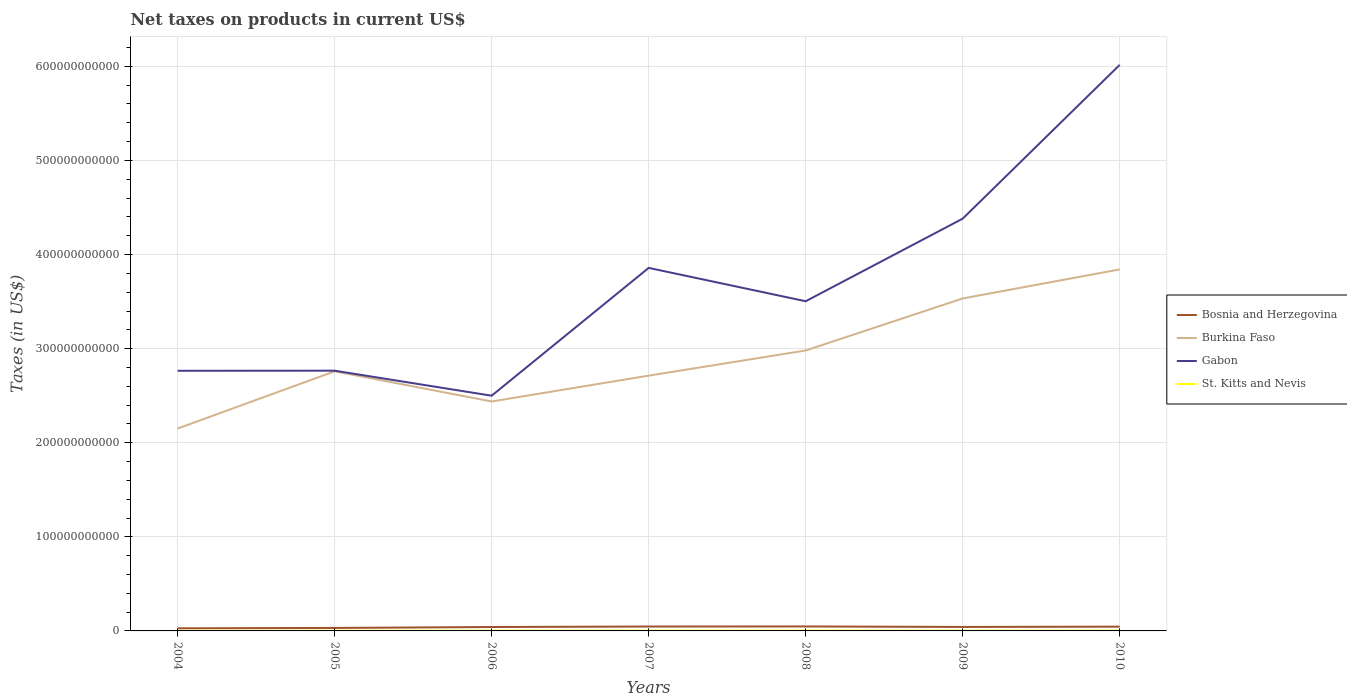Is the number of lines equal to the number of legend labels?
Make the answer very short. Yes. Across all years, what is the maximum net taxes on products in Bosnia and Herzegovina?
Make the answer very short. 2.77e+09. In which year was the net taxes on products in Gabon maximum?
Your answer should be very brief. 2006. What is the total net taxes on products in Gabon in the graph?
Provide a succinct answer. -1.63e+11. What is the difference between the highest and the second highest net taxes on products in Gabon?
Your answer should be compact. 3.52e+11. How many years are there in the graph?
Your answer should be compact. 7. What is the difference between two consecutive major ticks on the Y-axis?
Keep it short and to the point. 1.00e+11. Does the graph contain grids?
Provide a short and direct response. Yes. How are the legend labels stacked?
Your answer should be compact. Vertical. What is the title of the graph?
Give a very brief answer. Net taxes on products in current US$. What is the label or title of the Y-axis?
Offer a terse response. Taxes (in US$). What is the Taxes (in US$) of Bosnia and Herzegovina in 2004?
Your response must be concise. 2.77e+09. What is the Taxes (in US$) in Burkina Faso in 2004?
Give a very brief answer. 2.15e+11. What is the Taxes (in US$) of Gabon in 2004?
Provide a succinct answer. 2.76e+11. What is the Taxes (in US$) in St. Kitts and Nevis in 2004?
Keep it short and to the point. 1.77e+08. What is the Taxes (in US$) in Bosnia and Herzegovina in 2005?
Your answer should be very brief. 3.17e+09. What is the Taxes (in US$) in Burkina Faso in 2005?
Provide a short and direct response. 2.76e+11. What is the Taxes (in US$) in Gabon in 2005?
Ensure brevity in your answer.  2.77e+11. What is the Taxes (in US$) of St. Kitts and Nevis in 2005?
Your answer should be compact. 1.98e+08. What is the Taxes (in US$) in Bosnia and Herzegovina in 2006?
Make the answer very short. 4.14e+09. What is the Taxes (in US$) of Burkina Faso in 2006?
Make the answer very short. 2.44e+11. What is the Taxes (in US$) in Gabon in 2006?
Offer a terse response. 2.50e+11. What is the Taxes (in US$) of St. Kitts and Nevis in 2006?
Give a very brief answer. 2.50e+08. What is the Taxes (in US$) in Bosnia and Herzegovina in 2007?
Offer a very short reply. 4.68e+09. What is the Taxes (in US$) of Burkina Faso in 2007?
Provide a succinct answer. 2.71e+11. What is the Taxes (in US$) of Gabon in 2007?
Your answer should be very brief. 3.86e+11. What is the Taxes (in US$) in St. Kitts and Nevis in 2007?
Provide a succinct answer. 2.38e+08. What is the Taxes (in US$) of Bosnia and Herzegovina in 2008?
Offer a terse response. 4.75e+09. What is the Taxes (in US$) in Burkina Faso in 2008?
Keep it short and to the point. 2.98e+11. What is the Taxes (in US$) of Gabon in 2008?
Give a very brief answer. 3.50e+11. What is the Taxes (in US$) of St. Kitts and Nevis in 2008?
Make the answer very short. 2.68e+08. What is the Taxes (in US$) in Bosnia and Herzegovina in 2009?
Ensure brevity in your answer.  4.24e+09. What is the Taxes (in US$) in Burkina Faso in 2009?
Make the answer very short. 3.53e+11. What is the Taxes (in US$) in Gabon in 2009?
Your answer should be compact. 4.38e+11. What is the Taxes (in US$) of St. Kitts and Nevis in 2009?
Your answer should be very brief. 2.26e+08. What is the Taxes (in US$) in Bosnia and Herzegovina in 2010?
Provide a succinct answer. 4.54e+09. What is the Taxes (in US$) of Burkina Faso in 2010?
Give a very brief answer. 3.84e+11. What is the Taxes (in US$) in Gabon in 2010?
Ensure brevity in your answer.  6.02e+11. What is the Taxes (in US$) of St. Kitts and Nevis in 2010?
Provide a short and direct response. 2.31e+08. Across all years, what is the maximum Taxes (in US$) in Bosnia and Herzegovina?
Ensure brevity in your answer.  4.75e+09. Across all years, what is the maximum Taxes (in US$) of Burkina Faso?
Provide a short and direct response. 3.84e+11. Across all years, what is the maximum Taxes (in US$) in Gabon?
Provide a short and direct response. 6.02e+11. Across all years, what is the maximum Taxes (in US$) in St. Kitts and Nevis?
Your response must be concise. 2.68e+08. Across all years, what is the minimum Taxes (in US$) in Bosnia and Herzegovina?
Ensure brevity in your answer.  2.77e+09. Across all years, what is the minimum Taxes (in US$) of Burkina Faso?
Provide a short and direct response. 2.15e+11. Across all years, what is the minimum Taxes (in US$) in Gabon?
Your answer should be compact. 2.50e+11. Across all years, what is the minimum Taxes (in US$) in St. Kitts and Nevis?
Keep it short and to the point. 1.77e+08. What is the total Taxes (in US$) in Bosnia and Herzegovina in the graph?
Offer a very short reply. 2.83e+1. What is the total Taxes (in US$) in Burkina Faso in the graph?
Your answer should be compact. 2.04e+12. What is the total Taxes (in US$) of Gabon in the graph?
Ensure brevity in your answer.  2.58e+12. What is the total Taxes (in US$) in St. Kitts and Nevis in the graph?
Offer a terse response. 1.59e+09. What is the difference between the Taxes (in US$) of Bosnia and Herzegovina in 2004 and that in 2005?
Make the answer very short. -4.00e+08. What is the difference between the Taxes (in US$) in Burkina Faso in 2004 and that in 2005?
Keep it short and to the point. -6.08e+1. What is the difference between the Taxes (in US$) of Gabon in 2004 and that in 2005?
Your answer should be compact. -9.20e+07. What is the difference between the Taxes (in US$) in St. Kitts and Nevis in 2004 and that in 2005?
Offer a terse response. -2.11e+07. What is the difference between the Taxes (in US$) of Bosnia and Herzegovina in 2004 and that in 2006?
Make the answer very short. -1.38e+09. What is the difference between the Taxes (in US$) of Burkina Faso in 2004 and that in 2006?
Provide a succinct answer. -2.87e+1. What is the difference between the Taxes (in US$) of Gabon in 2004 and that in 2006?
Offer a very short reply. 2.65e+1. What is the difference between the Taxes (in US$) in St. Kitts and Nevis in 2004 and that in 2006?
Give a very brief answer. -7.34e+07. What is the difference between the Taxes (in US$) of Bosnia and Herzegovina in 2004 and that in 2007?
Keep it short and to the point. -1.91e+09. What is the difference between the Taxes (in US$) in Burkina Faso in 2004 and that in 2007?
Give a very brief answer. -5.62e+1. What is the difference between the Taxes (in US$) in Gabon in 2004 and that in 2007?
Your response must be concise. -1.09e+11. What is the difference between the Taxes (in US$) in St. Kitts and Nevis in 2004 and that in 2007?
Ensure brevity in your answer.  -6.18e+07. What is the difference between the Taxes (in US$) in Bosnia and Herzegovina in 2004 and that in 2008?
Ensure brevity in your answer.  -1.98e+09. What is the difference between the Taxes (in US$) in Burkina Faso in 2004 and that in 2008?
Your response must be concise. -8.30e+1. What is the difference between the Taxes (in US$) of Gabon in 2004 and that in 2008?
Ensure brevity in your answer.  -7.39e+1. What is the difference between the Taxes (in US$) of St. Kitts and Nevis in 2004 and that in 2008?
Offer a very short reply. -9.12e+07. What is the difference between the Taxes (in US$) in Bosnia and Herzegovina in 2004 and that in 2009?
Give a very brief answer. -1.47e+09. What is the difference between the Taxes (in US$) of Burkina Faso in 2004 and that in 2009?
Offer a very short reply. -1.38e+11. What is the difference between the Taxes (in US$) in Gabon in 2004 and that in 2009?
Ensure brevity in your answer.  -1.62e+11. What is the difference between the Taxes (in US$) of St. Kitts and Nevis in 2004 and that in 2009?
Ensure brevity in your answer.  -4.98e+07. What is the difference between the Taxes (in US$) of Bosnia and Herzegovina in 2004 and that in 2010?
Ensure brevity in your answer.  -1.77e+09. What is the difference between the Taxes (in US$) in Burkina Faso in 2004 and that in 2010?
Your answer should be very brief. -1.69e+11. What is the difference between the Taxes (in US$) of Gabon in 2004 and that in 2010?
Make the answer very short. -3.25e+11. What is the difference between the Taxes (in US$) of St. Kitts and Nevis in 2004 and that in 2010?
Keep it short and to the point. -5.47e+07. What is the difference between the Taxes (in US$) of Bosnia and Herzegovina in 2005 and that in 2006?
Your response must be concise. -9.76e+08. What is the difference between the Taxes (in US$) of Burkina Faso in 2005 and that in 2006?
Your answer should be compact. 3.21e+1. What is the difference between the Taxes (in US$) of Gabon in 2005 and that in 2006?
Your answer should be compact. 2.66e+1. What is the difference between the Taxes (in US$) in St. Kitts and Nevis in 2005 and that in 2006?
Provide a short and direct response. -5.24e+07. What is the difference between the Taxes (in US$) in Bosnia and Herzegovina in 2005 and that in 2007?
Make the answer very short. -1.51e+09. What is the difference between the Taxes (in US$) of Burkina Faso in 2005 and that in 2007?
Keep it short and to the point. 4.60e+09. What is the difference between the Taxes (in US$) in Gabon in 2005 and that in 2007?
Offer a terse response. -1.09e+11. What is the difference between the Taxes (in US$) in St. Kitts and Nevis in 2005 and that in 2007?
Give a very brief answer. -4.08e+07. What is the difference between the Taxes (in US$) of Bosnia and Herzegovina in 2005 and that in 2008?
Your response must be concise. -1.58e+09. What is the difference between the Taxes (in US$) of Burkina Faso in 2005 and that in 2008?
Offer a terse response. -2.21e+1. What is the difference between the Taxes (in US$) of Gabon in 2005 and that in 2008?
Keep it short and to the point. -7.38e+1. What is the difference between the Taxes (in US$) of St. Kitts and Nevis in 2005 and that in 2008?
Give a very brief answer. -7.01e+07. What is the difference between the Taxes (in US$) in Bosnia and Herzegovina in 2005 and that in 2009?
Your response must be concise. -1.07e+09. What is the difference between the Taxes (in US$) in Burkina Faso in 2005 and that in 2009?
Provide a succinct answer. -7.74e+1. What is the difference between the Taxes (in US$) of Gabon in 2005 and that in 2009?
Provide a succinct answer. -1.62e+11. What is the difference between the Taxes (in US$) of St. Kitts and Nevis in 2005 and that in 2009?
Make the answer very short. -2.87e+07. What is the difference between the Taxes (in US$) in Bosnia and Herzegovina in 2005 and that in 2010?
Offer a very short reply. -1.37e+09. What is the difference between the Taxes (in US$) in Burkina Faso in 2005 and that in 2010?
Give a very brief answer. -1.08e+11. What is the difference between the Taxes (in US$) in Gabon in 2005 and that in 2010?
Offer a terse response. -3.25e+11. What is the difference between the Taxes (in US$) of St. Kitts and Nevis in 2005 and that in 2010?
Give a very brief answer. -3.37e+07. What is the difference between the Taxes (in US$) in Bosnia and Herzegovina in 2006 and that in 2007?
Your answer should be compact. -5.37e+08. What is the difference between the Taxes (in US$) in Burkina Faso in 2006 and that in 2007?
Provide a succinct answer. -2.75e+1. What is the difference between the Taxes (in US$) of Gabon in 2006 and that in 2007?
Offer a very short reply. -1.36e+11. What is the difference between the Taxes (in US$) of St. Kitts and Nevis in 2006 and that in 2007?
Give a very brief answer. 1.16e+07. What is the difference between the Taxes (in US$) of Bosnia and Herzegovina in 2006 and that in 2008?
Your answer should be compact. -6.02e+08. What is the difference between the Taxes (in US$) in Burkina Faso in 2006 and that in 2008?
Offer a very short reply. -5.42e+1. What is the difference between the Taxes (in US$) of Gabon in 2006 and that in 2008?
Your answer should be very brief. -1.00e+11. What is the difference between the Taxes (in US$) of St. Kitts and Nevis in 2006 and that in 2008?
Your response must be concise. -1.77e+07. What is the difference between the Taxes (in US$) of Bosnia and Herzegovina in 2006 and that in 2009?
Your answer should be compact. -9.48e+07. What is the difference between the Taxes (in US$) in Burkina Faso in 2006 and that in 2009?
Your response must be concise. -1.09e+11. What is the difference between the Taxes (in US$) in Gabon in 2006 and that in 2009?
Make the answer very short. -1.88e+11. What is the difference between the Taxes (in US$) in St. Kitts and Nevis in 2006 and that in 2009?
Keep it short and to the point. 2.37e+07. What is the difference between the Taxes (in US$) in Bosnia and Herzegovina in 2006 and that in 2010?
Make the answer very short. -3.94e+08. What is the difference between the Taxes (in US$) in Burkina Faso in 2006 and that in 2010?
Offer a very short reply. -1.40e+11. What is the difference between the Taxes (in US$) of Gabon in 2006 and that in 2010?
Make the answer very short. -3.52e+11. What is the difference between the Taxes (in US$) in St. Kitts and Nevis in 2006 and that in 2010?
Your response must be concise. 1.87e+07. What is the difference between the Taxes (in US$) of Bosnia and Herzegovina in 2007 and that in 2008?
Give a very brief answer. -6.51e+07. What is the difference between the Taxes (in US$) of Burkina Faso in 2007 and that in 2008?
Provide a succinct answer. -2.67e+1. What is the difference between the Taxes (in US$) of Gabon in 2007 and that in 2008?
Your answer should be very brief. 3.54e+1. What is the difference between the Taxes (in US$) in St. Kitts and Nevis in 2007 and that in 2008?
Make the answer very short. -2.94e+07. What is the difference between the Taxes (in US$) of Bosnia and Herzegovina in 2007 and that in 2009?
Ensure brevity in your answer.  4.42e+08. What is the difference between the Taxes (in US$) in Burkina Faso in 2007 and that in 2009?
Make the answer very short. -8.20e+1. What is the difference between the Taxes (in US$) of Gabon in 2007 and that in 2009?
Keep it short and to the point. -5.23e+1. What is the difference between the Taxes (in US$) in St. Kitts and Nevis in 2007 and that in 2009?
Ensure brevity in your answer.  1.21e+07. What is the difference between the Taxes (in US$) of Bosnia and Herzegovina in 2007 and that in 2010?
Offer a terse response. 1.43e+08. What is the difference between the Taxes (in US$) of Burkina Faso in 2007 and that in 2010?
Keep it short and to the point. -1.13e+11. What is the difference between the Taxes (in US$) of Gabon in 2007 and that in 2010?
Your response must be concise. -2.16e+11. What is the difference between the Taxes (in US$) in St. Kitts and Nevis in 2007 and that in 2010?
Offer a very short reply. 7.09e+06. What is the difference between the Taxes (in US$) of Bosnia and Herzegovina in 2008 and that in 2009?
Offer a very short reply. 5.07e+08. What is the difference between the Taxes (in US$) in Burkina Faso in 2008 and that in 2009?
Your answer should be very brief. -5.53e+1. What is the difference between the Taxes (in US$) in Gabon in 2008 and that in 2009?
Keep it short and to the point. -8.78e+1. What is the difference between the Taxes (in US$) of St. Kitts and Nevis in 2008 and that in 2009?
Your answer should be compact. 4.14e+07. What is the difference between the Taxes (in US$) in Bosnia and Herzegovina in 2008 and that in 2010?
Your response must be concise. 2.08e+08. What is the difference between the Taxes (in US$) of Burkina Faso in 2008 and that in 2010?
Offer a very short reply. -8.61e+1. What is the difference between the Taxes (in US$) of Gabon in 2008 and that in 2010?
Your answer should be very brief. -2.51e+11. What is the difference between the Taxes (in US$) of St. Kitts and Nevis in 2008 and that in 2010?
Make the answer very short. 3.64e+07. What is the difference between the Taxes (in US$) in Bosnia and Herzegovina in 2009 and that in 2010?
Make the answer very short. -2.99e+08. What is the difference between the Taxes (in US$) of Burkina Faso in 2009 and that in 2010?
Provide a succinct answer. -3.09e+1. What is the difference between the Taxes (in US$) of Gabon in 2009 and that in 2010?
Keep it short and to the point. -1.63e+11. What is the difference between the Taxes (in US$) of St. Kitts and Nevis in 2009 and that in 2010?
Your answer should be compact. -4.97e+06. What is the difference between the Taxes (in US$) of Bosnia and Herzegovina in 2004 and the Taxes (in US$) of Burkina Faso in 2005?
Your answer should be compact. -2.73e+11. What is the difference between the Taxes (in US$) of Bosnia and Herzegovina in 2004 and the Taxes (in US$) of Gabon in 2005?
Offer a very short reply. -2.74e+11. What is the difference between the Taxes (in US$) in Bosnia and Herzegovina in 2004 and the Taxes (in US$) in St. Kitts and Nevis in 2005?
Keep it short and to the point. 2.57e+09. What is the difference between the Taxes (in US$) of Burkina Faso in 2004 and the Taxes (in US$) of Gabon in 2005?
Your answer should be very brief. -6.15e+1. What is the difference between the Taxes (in US$) in Burkina Faso in 2004 and the Taxes (in US$) in St. Kitts and Nevis in 2005?
Your answer should be compact. 2.15e+11. What is the difference between the Taxes (in US$) in Gabon in 2004 and the Taxes (in US$) in St. Kitts and Nevis in 2005?
Your answer should be very brief. 2.76e+11. What is the difference between the Taxes (in US$) in Bosnia and Herzegovina in 2004 and the Taxes (in US$) in Burkina Faso in 2006?
Give a very brief answer. -2.41e+11. What is the difference between the Taxes (in US$) of Bosnia and Herzegovina in 2004 and the Taxes (in US$) of Gabon in 2006?
Make the answer very short. -2.47e+11. What is the difference between the Taxes (in US$) of Bosnia and Herzegovina in 2004 and the Taxes (in US$) of St. Kitts and Nevis in 2006?
Offer a terse response. 2.52e+09. What is the difference between the Taxes (in US$) of Burkina Faso in 2004 and the Taxes (in US$) of Gabon in 2006?
Ensure brevity in your answer.  -3.49e+1. What is the difference between the Taxes (in US$) in Burkina Faso in 2004 and the Taxes (in US$) in St. Kitts and Nevis in 2006?
Provide a short and direct response. 2.15e+11. What is the difference between the Taxes (in US$) of Gabon in 2004 and the Taxes (in US$) of St. Kitts and Nevis in 2006?
Ensure brevity in your answer.  2.76e+11. What is the difference between the Taxes (in US$) of Bosnia and Herzegovina in 2004 and the Taxes (in US$) of Burkina Faso in 2007?
Your response must be concise. -2.69e+11. What is the difference between the Taxes (in US$) in Bosnia and Herzegovina in 2004 and the Taxes (in US$) in Gabon in 2007?
Offer a terse response. -3.83e+11. What is the difference between the Taxes (in US$) in Bosnia and Herzegovina in 2004 and the Taxes (in US$) in St. Kitts and Nevis in 2007?
Your answer should be very brief. 2.53e+09. What is the difference between the Taxes (in US$) of Burkina Faso in 2004 and the Taxes (in US$) of Gabon in 2007?
Ensure brevity in your answer.  -1.71e+11. What is the difference between the Taxes (in US$) in Burkina Faso in 2004 and the Taxes (in US$) in St. Kitts and Nevis in 2007?
Your answer should be compact. 2.15e+11. What is the difference between the Taxes (in US$) in Gabon in 2004 and the Taxes (in US$) in St. Kitts and Nevis in 2007?
Provide a succinct answer. 2.76e+11. What is the difference between the Taxes (in US$) of Bosnia and Herzegovina in 2004 and the Taxes (in US$) of Burkina Faso in 2008?
Your response must be concise. -2.95e+11. What is the difference between the Taxes (in US$) of Bosnia and Herzegovina in 2004 and the Taxes (in US$) of Gabon in 2008?
Ensure brevity in your answer.  -3.48e+11. What is the difference between the Taxes (in US$) of Bosnia and Herzegovina in 2004 and the Taxes (in US$) of St. Kitts and Nevis in 2008?
Provide a short and direct response. 2.50e+09. What is the difference between the Taxes (in US$) of Burkina Faso in 2004 and the Taxes (in US$) of Gabon in 2008?
Ensure brevity in your answer.  -1.35e+11. What is the difference between the Taxes (in US$) of Burkina Faso in 2004 and the Taxes (in US$) of St. Kitts and Nevis in 2008?
Offer a very short reply. 2.15e+11. What is the difference between the Taxes (in US$) in Gabon in 2004 and the Taxes (in US$) in St. Kitts and Nevis in 2008?
Provide a short and direct response. 2.76e+11. What is the difference between the Taxes (in US$) in Bosnia and Herzegovina in 2004 and the Taxes (in US$) in Burkina Faso in 2009?
Give a very brief answer. -3.51e+11. What is the difference between the Taxes (in US$) in Bosnia and Herzegovina in 2004 and the Taxes (in US$) in Gabon in 2009?
Your answer should be very brief. -4.35e+11. What is the difference between the Taxes (in US$) in Bosnia and Herzegovina in 2004 and the Taxes (in US$) in St. Kitts and Nevis in 2009?
Keep it short and to the point. 2.54e+09. What is the difference between the Taxes (in US$) in Burkina Faso in 2004 and the Taxes (in US$) in Gabon in 2009?
Give a very brief answer. -2.23e+11. What is the difference between the Taxes (in US$) in Burkina Faso in 2004 and the Taxes (in US$) in St. Kitts and Nevis in 2009?
Provide a short and direct response. 2.15e+11. What is the difference between the Taxes (in US$) of Gabon in 2004 and the Taxes (in US$) of St. Kitts and Nevis in 2009?
Your answer should be very brief. 2.76e+11. What is the difference between the Taxes (in US$) of Bosnia and Herzegovina in 2004 and the Taxes (in US$) of Burkina Faso in 2010?
Make the answer very short. -3.81e+11. What is the difference between the Taxes (in US$) in Bosnia and Herzegovina in 2004 and the Taxes (in US$) in Gabon in 2010?
Offer a very short reply. -5.99e+11. What is the difference between the Taxes (in US$) in Bosnia and Herzegovina in 2004 and the Taxes (in US$) in St. Kitts and Nevis in 2010?
Your response must be concise. 2.54e+09. What is the difference between the Taxes (in US$) in Burkina Faso in 2004 and the Taxes (in US$) in Gabon in 2010?
Keep it short and to the point. -3.86e+11. What is the difference between the Taxes (in US$) in Burkina Faso in 2004 and the Taxes (in US$) in St. Kitts and Nevis in 2010?
Your answer should be compact. 2.15e+11. What is the difference between the Taxes (in US$) in Gabon in 2004 and the Taxes (in US$) in St. Kitts and Nevis in 2010?
Provide a succinct answer. 2.76e+11. What is the difference between the Taxes (in US$) in Bosnia and Herzegovina in 2005 and the Taxes (in US$) in Burkina Faso in 2006?
Ensure brevity in your answer.  -2.41e+11. What is the difference between the Taxes (in US$) in Bosnia and Herzegovina in 2005 and the Taxes (in US$) in Gabon in 2006?
Ensure brevity in your answer.  -2.47e+11. What is the difference between the Taxes (in US$) of Bosnia and Herzegovina in 2005 and the Taxes (in US$) of St. Kitts and Nevis in 2006?
Ensure brevity in your answer.  2.92e+09. What is the difference between the Taxes (in US$) in Burkina Faso in 2005 and the Taxes (in US$) in Gabon in 2006?
Ensure brevity in your answer.  2.59e+1. What is the difference between the Taxes (in US$) of Burkina Faso in 2005 and the Taxes (in US$) of St. Kitts and Nevis in 2006?
Your answer should be compact. 2.76e+11. What is the difference between the Taxes (in US$) of Gabon in 2005 and the Taxes (in US$) of St. Kitts and Nevis in 2006?
Provide a short and direct response. 2.76e+11. What is the difference between the Taxes (in US$) of Bosnia and Herzegovina in 2005 and the Taxes (in US$) of Burkina Faso in 2007?
Offer a terse response. -2.68e+11. What is the difference between the Taxes (in US$) in Bosnia and Herzegovina in 2005 and the Taxes (in US$) in Gabon in 2007?
Offer a very short reply. -3.83e+11. What is the difference between the Taxes (in US$) of Bosnia and Herzegovina in 2005 and the Taxes (in US$) of St. Kitts and Nevis in 2007?
Your answer should be very brief. 2.93e+09. What is the difference between the Taxes (in US$) of Burkina Faso in 2005 and the Taxes (in US$) of Gabon in 2007?
Provide a short and direct response. -1.10e+11. What is the difference between the Taxes (in US$) in Burkina Faso in 2005 and the Taxes (in US$) in St. Kitts and Nevis in 2007?
Provide a short and direct response. 2.76e+11. What is the difference between the Taxes (in US$) in Gabon in 2005 and the Taxes (in US$) in St. Kitts and Nevis in 2007?
Your answer should be very brief. 2.76e+11. What is the difference between the Taxes (in US$) in Bosnia and Herzegovina in 2005 and the Taxes (in US$) in Burkina Faso in 2008?
Your response must be concise. -2.95e+11. What is the difference between the Taxes (in US$) of Bosnia and Herzegovina in 2005 and the Taxes (in US$) of Gabon in 2008?
Your answer should be very brief. -3.47e+11. What is the difference between the Taxes (in US$) of Bosnia and Herzegovina in 2005 and the Taxes (in US$) of St. Kitts and Nevis in 2008?
Give a very brief answer. 2.90e+09. What is the difference between the Taxes (in US$) of Burkina Faso in 2005 and the Taxes (in US$) of Gabon in 2008?
Your answer should be compact. -7.45e+1. What is the difference between the Taxes (in US$) of Burkina Faso in 2005 and the Taxes (in US$) of St. Kitts and Nevis in 2008?
Offer a very short reply. 2.76e+11. What is the difference between the Taxes (in US$) of Gabon in 2005 and the Taxes (in US$) of St. Kitts and Nevis in 2008?
Ensure brevity in your answer.  2.76e+11. What is the difference between the Taxes (in US$) of Bosnia and Herzegovina in 2005 and the Taxes (in US$) of Burkina Faso in 2009?
Provide a short and direct response. -3.50e+11. What is the difference between the Taxes (in US$) of Bosnia and Herzegovina in 2005 and the Taxes (in US$) of Gabon in 2009?
Offer a very short reply. -4.35e+11. What is the difference between the Taxes (in US$) in Bosnia and Herzegovina in 2005 and the Taxes (in US$) in St. Kitts and Nevis in 2009?
Give a very brief answer. 2.94e+09. What is the difference between the Taxes (in US$) of Burkina Faso in 2005 and the Taxes (in US$) of Gabon in 2009?
Your answer should be compact. -1.62e+11. What is the difference between the Taxes (in US$) of Burkina Faso in 2005 and the Taxes (in US$) of St. Kitts and Nevis in 2009?
Your response must be concise. 2.76e+11. What is the difference between the Taxes (in US$) in Gabon in 2005 and the Taxes (in US$) in St. Kitts and Nevis in 2009?
Your response must be concise. 2.76e+11. What is the difference between the Taxes (in US$) of Bosnia and Herzegovina in 2005 and the Taxes (in US$) of Burkina Faso in 2010?
Provide a succinct answer. -3.81e+11. What is the difference between the Taxes (in US$) in Bosnia and Herzegovina in 2005 and the Taxes (in US$) in Gabon in 2010?
Keep it short and to the point. -5.98e+11. What is the difference between the Taxes (in US$) in Bosnia and Herzegovina in 2005 and the Taxes (in US$) in St. Kitts and Nevis in 2010?
Your answer should be very brief. 2.94e+09. What is the difference between the Taxes (in US$) of Burkina Faso in 2005 and the Taxes (in US$) of Gabon in 2010?
Your response must be concise. -3.26e+11. What is the difference between the Taxes (in US$) in Burkina Faso in 2005 and the Taxes (in US$) in St. Kitts and Nevis in 2010?
Offer a very short reply. 2.76e+11. What is the difference between the Taxes (in US$) of Gabon in 2005 and the Taxes (in US$) of St. Kitts and Nevis in 2010?
Make the answer very short. 2.76e+11. What is the difference between the Taxes (in US$) in Bosnia and Herzegovina in 2006 and the Taxes (in US$) in Burkina Faso in 2007?
Your answer should be compact. -2.67e+11. What is the difference between the Taxes (in US$) of Bosnia and Herzegovina in 2006 and the Taxes (in US$) of Gabon in 2007?
Give a very brief answer. -3.82e+11. What is the difference between the Taxes (in US$) in Bosnia and Herzegovina in 2006 and the Taxes (in US$) in St. Kitts and Nevis in 2007?
Make the answer very short. 3.90e+09. What is the difference between the Taxes (in US$) in Burkina Faso in 2006 and the Taxes (in US$) in Gabon in 2007?
Offer a terse response. -1.42e+11. What is the difference between the Taxes (in US$) in Burkina Faso in 2006 and the Taxes (in US$) in St. Kitts and Nevis in 2007?
Offer a very short reply. 2.44e+11. What is the difference between the Taxes (in US$) in Gabon in 2006 and the Taxes (in US$) in St. Kitts and Nevis in 2007?
Provide a short and direct response. 2.50e+11. What is the difference between the Taxes (in US$) in Bosnia and Herzegovina in 2006 and the Taxes (in US$) in Burkina Faso in 2008?
Keep it short and to the point. -2.94e+11. What is the difference between the Taxes (in US$) of Bosnia and Herzegovina in 2006 and the Taxes (in US$) of Gabon in 2008?
Make the answer very short. -3.46e+11. What is the difference between the Taxes (in US$) in Bosnia and Herzegovina in 2006 and the Taxes (in US$) in St. Kitts and Nevis in 2008?
Keep it short and to the point. 3.88e+09. What is the difference between the Taxes (in US$) of Burkina Faso in 2006 and the Taxes (in US$) of Gabon in 2008?
Offer a terse response. -1.07e+11. What is the difference between the Taxes (in US$) in Burkina Faso in 2006 and the Taxes (in US$) in St. Kitts and Nevis in 2008?
Your answer should be compact. 2.44e+11. What is the difference between the Taxes (in US$) in Gabon in 2006 and the Taxes (in US$) in St. Kitts and Nevis in 2008?
Give a very brief answer. 2.50e+11. What is the difference between the Taxes (in US$) in Bosnia and Herzegovina in 2006 and the Taxes (in US$) in Burkina Faso in 2009?
Your answer should be very brief. -3.49e+11. What is the difference between the Taxes (in US$) of Bosnia and Herzegovina in 2006 and the Taxes (in US$) of Gabon in 2009?
Your answer should be very brief. -4.34e+11. What is the difference between the Taxes (in US$) in Bosnia and Herzegovina in 2006 and the Taxes (in US$) in St. Kitts and Nevis in 2009?
Keep it short and to the point. 3.92e+09. What is the difference between the Taxes (in US$) in Burkina Faso in 2006 and the Taxes (in US$) in Gabon in 2009?
Make the answer very short. -1.94e+11. What is the difference between the Taxes (in US$) in Burkina Faso in 2006 and the Taxes (in US$) in St. Kitts and Nevis in 2009?
Your answer should be compact. 2.44e+11. What is the difference between the Taxes (in US$) in Gabon in 2006 and the Taxes (in US$) in St. Kitts and Nevis in 2009?
Ensure brevity in your answer.  2.50e+11. What is the difference between the Taxes (in US$) in Bosnia and Herzegovina in 2006 and the Taxes (in US$) in Burkina Faso in 2010?
Keep it short and to the point. -3.80e+11. What is the difference between the Taxes (in US$) of Bosnia and Herzegovina in 2006 and the Taxes (in US$) of Gabon in 2010?
Your response must be concise. -5.97e+11. What is the difference between the Taxes (in US$) in Bosnia and Herzegovina in 2006 and the Taxes (in US$) in St. Kitts and Nevis in 2010?
Your answer should be very brief. 3.91e+09. What is the difference between the Taxes (in US$) of Burkina Faso in 2006 and the Taxes (in US$) of Gabon in 2010?
Ensure brevity in your answer.  -3.58e+11. What is the difference between the Taxes (in US$) in Burkina Faso in 2006 and the Taxes (in US$) in St. Kitts and Nevis in 2010?
Your answer should be compact. 2.44e+11. What is the difference between the Taxes (in US$) of Gabon in 2006 and the Taxes (in US$) of St. Kitts and Nevis in 2010?
Offer a very short reply. 2.50e+11. What is the difference between the Taxes (in US$) of Bosnia and Herzegovina in 2007 and the Taxes (in US$) of Burkina Faso in 2008?
Your answer should be very brief. -2.93e+11. What is the difference between the Taxes (in US$) in Bosnia and Herzegovina in 2007 and the Taxes (in US$) in Gabon in 2008?
Offer a terse response. -3.46e+11. What is the difference between the Taxes (in US$) in Bosnia and Herzegovina in 2007 and the Taxes (in US$) in St. Kitts and Nevis in 2008?
Your answer should be very brief. 4.41e+09. What is the difference between the Taxes (in US$) of Burkina Faso in 2007 and the Taxes (in US$) of Gabon in 2008?
Provide a short and direct response. -7.91e+1. What is the difference between the Taxes (in US$) in Burkina Faso in 2007 and the Taxes (in US$) in St. Kitts and Nevis in 2008?
Provide a succinct answer. 2.71e+11. What is the difference between the Taxes (in US$) of Gabon in 2007 and the Taxes (in US$) of St. Kitts and Nevis in 2008?
Offer a very short reply. 3.86e+11. What is the difference between the Taxes (in US$) of Bosnia and Herzegovina in 2007 and the Taxes (in US$) of Burkina Faso in 2009?
Offer a terse response. -3.49e+11. What is the difference between the Taxes (in US$) in Bosnia and Herzegovina in 2007 and the Taxes (in US$) in Gabon in 2009?
Provide a short and direct response. -4.33e+11. What is the difference between the Taxes (in US$) of Bosnia and Herzegovina in 2007 and the Taxes (in US$) of St. Kitts and Nevis in 2009?
Provide a short and direct response. 4.45e+09. What is the difference between the Taxes (in US$) in Burkina Faso in 2007 and the Taxes (in US$) in Gabon in 2009?
Your answer should be very brief. -1.67e+11. What is the difference between the Taxes (in US$) in Burkina Faso in 2007 and the Taxes (in US$) in St. Kitts and Nevis in 2009?
Keep it short and to the point. 2.71e+11. What is the difference between the Taxes (in US$) in Gabon in 2007 and the Taxes (in US$) in St. Kitts and Nevis in 2009?
Offer a terse response. 3.86e+11. What is the difference between the Taxes (in US$) in Bosnia and Herzegovina in 2007 and the Taxes (in US$) in Burkina Faso in 2010?
Offer a terse response. -3.80e+11. What is the difference between the Taxes (in US$) of Bosnia and Herzegovina in 2007 and the Taxes (in US$) of Gabon in 2010?
Your answer should be compact. -5.97e+11. What is the difference between the Taxes (in US$) in Bosnia and Herzegovina in 2007 and the Taxes (in US$) in St. Kitts and Nevis in 2010?
Keep it short and to the point. 4.45e+09. What is the difference between the Taxes (in US$) of Burkina Faso in 2007 and the Taxes (in US$) of Gabon in 2010?
Offer a very short reply. -3.30e+11. What is the difference between the Taxes (in US$) in Burkina Faso in 2007 and the Taxes (in US$) in St. Kitts and Nevis in 2010?
Your response must be concise. 2.71e+11. What is the difference between the Taxes (in US$) in Gabon in 2007 and the Taxes (in US$) in St. Kitts and Nevis in 2010?
Provide a short and direct response. 3.86e+11. What is the difference between the Taxes (in US$) in Bosnia and Herzegovina in 2008 and the Taxes (in US$) in Burkina Faso in 2009?
Give a very brief answer. -3.49e+11. What is the difference between the Taxes (in US$) of Bosnia and Herzegovina in 2008 and the Taxes (in US$) of Gabon in 2009?
Your answer should be compact. -4.33e+11. What is the difference between the Taxes (in US$) of Bosnia and Herzegovina in 2008 and the Taxes (in US$) of St. Kitts and Nevis in 2009?
Provide a short and direct response. 4.52e+09. What is the difference between the Taxes (in US$) in Burkina Faso in 2008 and the Taxes (in US$) in Gabon in 2009?
Ensure brevity in your answer.  -1.40e+11. What is the difference between the Taxes (in US$) in Burkina Faso in 2008 and the Taxes (in US$) in St. Kitts and Nevis in 2009?
Make the answer very short. 2.98e+11. What is the difference between the Taxes (in US$) in Gabon in 2008 and the Taxes (in US$) in St. Kitts and Nevis in 2009?
Ensure brevity in your answer.  3.50e+11. What is the difference between the Taxes (in US$) of Bosnia and Herzegovina in 2008 and the Taxes (in US$) of Burkina Faso in 2010?
Your response must be concise. -3.79e+11. What is the difference between the Taxes (in US$) in Bosnia and Herzegovina in 2008 and the Taxes (in US$) in Gabon in 2010?
Your answer should be compact. -5.97e+11. What is the difference between the Taxes (in US$) of Bosnia and Herzegovina in 2008 and the Taxes (in US$) of St. Kitts and Nevis in 2010?
Offer a very short reply. 4.51e+09. What is the difference between the Taxes (in US$) of Burkina Faso in 2008 and the Taxes (in US$) of Gabon in 2010?
Provide a short and direct response. -3.04e+11. What is the difference between the Taxes (in US$) of Burkina Faso in 2008 and the Taxes (in US$) of St. Kitts and Nevis in 2010?
Provide a succinct answer. 2.98e+11. What is the difference between the Taxes (in US$) of Gabon in 2008 and the Taxes (in US$) of St. Kitts and Nevis in 2010?
Keep it short and to the point. 3.50e+11. What is the difference between the Taxes (in US$) of Bosnia and Herzegovina in 2009 and the Taxes (in US$) of Burkina Faso in 2010?
Your response must be concise. -3.80e+11. What is the difference between the Taxes (in US$) of Bosnia and Herzegovina in 2009 and the Taxes (in US$) of Gabon in 2010?
Give a very brief answer. -5.97e+11. What is the difference between the Taxes (in US$) in Bosnia and Herzegovina in 2009 and the Taxes (in US$) in St. Kitts and Nevis in 2010?
Your answer should be compact. 4.01e+09. What is the difference between the Taxes (in US$) of Burkina Faso in 2009 and the Taxes (in US$) of Gabon in 2010?
Offer a very short reply. -2.48e+11. What is the difference between the Taxes (in US$) in Burkina Faso in 2009 and the Taxes (in US$) in St. Kitts and Nevis in 2010?
Provide a succinct answer. 3.53e+11. What is the difference between the Taxes (in US$) in Gabon in 2009 and the Taxes (in US$) in St. Kitts and Nevis in 2010?
Give a very brief answer. 4.38e+11. What is the average Taxes (in US$) in Bosnia and Herzegovina per year?
Ensure brevity in your answer.  4.04e+09. What is the average Taxes (in US$) of Burkina Faso per year?
Your answer should be very brief. 2.92e+11. What is the average Taxes (in US$) of Gabon per year?
Offer a very short reply. 3.68e+11. What is the average Taxes (in US$) of St. Kitts and Nevis per year?
Provide a short and direct response. 2.27e+08. In the year 2004, what is the difference between the Taxes (in US$) of Bosnia and Herzegovina and Taxes (in US$) of Burkina Faso?
Give a very brief answer. -2.12e+11. In the year 2004, what is the difference between the Taxes (in US$) of Bosnia and Herzegovina and Taxes (in US$) of Gabon?
Offer a very short reply. -2.74e+11. In the year 2004, what is the difference between the Taxes (in US$) of Bosnia and Herzegovina and Taxes (in US$) of St. Kitts and Nevis?
Give a very brief answer. 2.59e+09. In the year 2004, what is the difference between the Taxes (in US$) in Burkina Faso and Taxes (in US$) in Gabon?
Offer a very short reply. -6.14e+1. In the year 2004, what is the difference between the Taxes (in US$) of Burkina Faso and Taxes (in US$) of St. Kitts and Nevis?
Provide a succinct answer. 2.15e+11. In the year 2004, what is the difference between the Taxes (in US$) of Gabon and Taxes (in US$) of St. Kitts and Nevis?
Provide a short and direct response. 2.76e+11. In the year 2005, what is the difference between the Taxes (in US$) of Bosnia and Herzegovina and Taxes (in US$) of Burkina Faso?
Your answer should be very brief. -2.73e+11. In the year 2005, what is the difference between the Taxes (in US$) in Bosnia and Herzegovina and Taxes (in US$) in Gabon?
Your answer should be very brief. -2.73e+11. In the year 2005, what is the difference between the Taxes (in US$) in Bosnia and Herzegovina and Taxes (in US$) in St. Kitts and Nevis?
Provide a short and direct response. 2.97e+09. In the year 2005, what is the difference between the Taxes (in US$) in Burkina Faso and Taxes (in US$) in Gabon?
Your response must be concise. -6.57e+08. In the year 2005, what is the difference between the Taxes (in US$) in Burkina Faso and Taxes (in US$) in St. Kitts and Nevis?
Offer a terse response. 2.76e+11. In the year 2005, what is the difference between the Taxes (in US$) of Gabon and Taxes (in US$) of St. Kitts and Nevis?
Offer a terse response. 2.76e+11. In the year 2006, what is the difference between the Taxes (in US$) of Bosnia and Herzegovina and Taxes (in US$) of Burkina Faso?
Offer a terse response. -2.40e+11. In the year 2006, what is the difference between the Taxes (in US$) of Bosnia and Herzegovina and Taxes (in US$) of Gabon?
Offer a terse response. -2.46e+11. In the year 2006, what is the difference between the Taxes (in US$) in Bosnia and Herzegovina and Taxes (in US$) in St. Kitts and Nevis?
Your answer should be compact. 3.89e+09. In the year 2006, what is the difference between the Taxes (in US$) in Burkina Faso and Taxes (in US$) in Gabon?
Offer a terse response. -6.14e+09. In the year 2006, what is the difference between the Taxes (in US$) in Burkina Faso and Taxes (in US$) in St. Kitts and Nevis?
Your response must be concise. 2.44e+11. In the year 2006, what is the difference between the Taxes (in US$) of Gabon and Taxes (in US$) of St. Kitts and Nevis?
Offer a very short reply. 2.50e+11. In the year 2007, what is the difference between the Taxes (in US$) in Bosnia and Herzegovina and Taxes (in US$) in Burkina Faso?
Ensure brevity in your answer.  -2.67e+11. In the year 2007, what is the difference between the Taxes (in US$) of Bosnia and Herzegovina and Taxes (in US$) of Gabon?
Offer a very short reply. -3.81e+11. In the year 2007, what is the difference between the Taxes (in US$) in Bosnia and Herzegovina and Taxes (in US$) in St. Kitts and Nevis?
Your answer should be very brief. 4.44e+09. In the year 2007, what is the difference between the Taxes (in US$) of Burkina Faso and Taxes (in US$) of Gabon?
Provide a short and direct response. -1.14e+11. In the year 2007, what is the difference between the Taxes (in US$) in Burkina Faso and Taxes (in US$) in St. Kitts and Nevis?
Offer a terse response. 2.71e+11. In the year 2007, what is the difference between the Taxes (in US$) in Gabon and Taxes (in US$) in St. Kitts and Nevis?
Ensure brevity in your answer.  3.86e+11. In the year 2008, what is the difference between the Taxes (in US$) of Bosnia and Herzegovina and Taxes (in US$) of Burkina Faso?
Offer a terse response. -2.93e+11. In the year 2008, what is the difference between the Taxes (in US$) in Bosnia and Herzegovina and Taxes (in US$) in Gabon?
Provide a short and direct response. -3.46e+11. In the year 2008, what is the difference between the Taxes (in US$) in Bosnia and Herzegovina and Taxes (in US$) in St. Kitts and Nevis?
Make the answer very short. 4.48e+09. In the year 2008, what is the difference between the Taxes (in US$) in Burkina Faso and Taxes (in US$) in Gabon?
Ensure brevity in your answer.  -5.23e+1. In the year 2008, what is the difference between the Taxes (in US$) in Burkina Faso and Taxes (in US$) in St. Kitts and Nevis?
Offer a very short reply. 2.98e+11. In the year 2008, what is the difference between the Taxes (in US$) in Gabon and Taxes (in US$) in St. Kitts and Nevis?
Your answer should be compact. 3.50e+11. In the year 2009, what is the difference between the Taxes (in US$) of Bosnia and Herzegovina and Taxes (in US$) of Burkina Faso?
Your response must be concise. -3.49e+11. In the year 2009, what is the difference between the Taxes (in US$) of Bosnia and Herzegovina and Taxes (in US$) of Gabon?
Your response must be concise. -4.34e+11. In the year 2009, what is the difference between the Taxes (in US$) in Bosnia and Herzegovina and Taxes (in US$) in St. Kitts and Nevis?
Offer a terse response. 4.01e+09. In the year 2009, what is the difference between the Taxes (in US$) of Burkina Faso and Taxes (in US$) of Gabon?
Your answer should be compact. -8.48e+1. In the year 2009, what is the difference between the Taxes (in US$) of Burkina Faso and Taxes (in US$) of St. Kitts and Nevis?
Your response must be concise. 3.53e+11. In the year 2009, what is the difference between the Taxes (in US$) of Gabon and Taxes (in US$) of St. Kitts and Nevis?
Your response must be concise. 4.38e+11. In the year 2010, what is the difference between the Taxes (in US$) in Bosnia and Herzegovina and Taxes (in US$) in Burkina Faso?
Offer a terse response. -3.80e+11. In the year 2010, what is the difference between the Taxes (in US$) of Bosnia and Herzegovina and Taxes (in US$) of Gabon?
Offer a very short reply. -5.97e+11. In the year 2010, what is the difference between the Taxes (in US$) in Bosnia and Herzegovina and Taxes (in US$) in St. Kitts and Nevis?
Your response must be concise. 4.31e+09. In the year 2010, what is the difference between the Taxes (in US$) of Burkina Faso and Taxes (in US$) of Gabon?
Offer a terse response. -2.17e+11. In the year 2010, what is the difference between the Taxes (in US$) of Burkina Faso and Taxes (in US$) of St. Kitts and Nevis?
Make the answer very short. 3.84e+11. In the year 2010, what is the difference between the Taxes (in US$) of Gabon and Taxes (in US$) of St. Kitts and Nevis?
Keep it short and to the point. 6.01e+11. What is the ratio of the Taxes (in US$) in Bosnia and Herzegovina in 2004 to that in 2005?
Your response must be concise. 0.87. What is the ratio of the Taxes (in US$) of Burkina Faso in 2004 to that in 2005?
Provide a succinct answer. 0.78. What is the ratio of the Taxes (in US$) of St. Kitts and Nevis in 2004 to that in 2005?
Make the answer very short. 0.89. What is the ratio of the Taxes (in US$) of Bosnia and Herzegovina in 2004 to that in 2006?
Your answer should be very brief. 0.67. What is the ratio of the Taxes (in US$) of Burkina Faso in 2004 to that in 2006?
Your response must be concise. 0.88. What is the ratio of the Taxes (in US$) of Gabon in 2004 to that in 2006?
Ensure brevity in your answer.  1.11. What is the ratio of the Taxes (in US$) in St. Kitts and Nevis in 2004 to that in 2006?
Your answer should be very brief. 0.71. What is the ratio of the Taxes (in US$) in Bosnia and Herzegovina in 2004 to that in 2007?
Offer a terse response. 0.59. What is the ratio of the Taxes (in US$) of Burkina Faso in 2004 to that in 2007?
Your answer should be very brief. 0.79. What is the ratio of the Taxes (in US$) of Gabon in 2004 to that in 2007?
Give a very brief answer. 0.72. What is the ratio of the Taxes (in US$) in St. Kitts and Nevis in 2004 to that in 2007?
Ensure brevity in your answer.  0.74. What is the ratio of the Taxes (in US$) in Bosnia and Herzegovina in 2004 to that in 2008?
Offer a terse response. 0.58. What is the ratio of the Taxes (in US$) in Burkina Faso in 2004 to that in 2008?
Give a very brief answer. 0.72. What is the ratio of the Taxes (in US$) of Gabon in 2004 to that in 2008?
Provide a short and direct response. 0.79. What is the ratio of the Taxes (in US$) of St. Kitts and Nevis in 2004 to that in 2008?
Provide a succinct answer. 0.66. What is the ratio of the Taxes (in US$) in Bosnia and Herzegovina in 2004 to that in 2009?
Offer a terse response. 0.65. What is the ratio of the Taxes (in US$) of Burkina Faso in 2004 to that in 2009?
Provide a succinct answer. 0.61. What is the ratio of the Taxes (in US$) of Gabon in 2004 to that in 2009?
Your answer should be very brief. 0.63. What is the ratio of the Taxes (in US$) of St. Kitts and Nevis in 2004 to that in 2009?
Offer a terse response. 0.78. What is the ratio of the Taxes (in US$) in Bosnia and Herzegovina in 2004 to that in 2010?
Offer a very short reply. 0.61. What is the ratio of the Taxes (in US$) in Burkina Faso in 2004 to that in 2010?
Your answer should be very brief. 0.56. What is the ratio of the Taxes (in US$) in Gabon in 2004 to that in 2010?
Your response must be concise. 0.46. What is the ratio of the Taxes (in US$) of St. Kitts and Nevis in 2004 to that in 2010?
Your answer should be very brief. 0.76. What is the ratio of the Taxes (in US$) in Bosnia and Herzegovina in 2005 to that in 2006?
Offer a terse response. 0.76. What is the ratio of the Taxes (in US$) of Burkina Faso in 2005 to that in 2006?
Offer a very short reply. 1.13. What is the ratio of the Taxes (in US$) of Gabon in 2005 to that in 2006?
Offer a terse response. 1.11. What is the ratio of the Taxes (in US$) in St. Kitts and Nevis in 2005 to that in 2006?
Provide a short and direct response. 0.79. What is the ratio of the Taxes (in US$) of Bosnia and Herzegovina in 2005 to that in 2007?
Offer a very short reply. 0.68. What is the ratio of the Taxes (in US$) of Burkina Faso in 2005 to that in 2007?
Your response must be concise. 1.02. What is the ratio of the Taxes (in US$) of Gabon in 2005 to that in 2007?
Your response must be concise. 0.72. What is the ratio of the Taxes (in US$) of St. Kitts and Nevis in 2005 to that in 2007?
Offer a terse response. 0.83. What is the ratio of the Taxes (in US$) of Bosnia and Herzegovina in 2005 to that in 2008?
Give a very brief answer. 0.67. What is the ratio of the Taxes (in US$) of Burkina Faso in 2005 to that in 2008?
Keep it short and to the point. 0.93. What is the ratio of the Taxes (in US$) of Gabon in 2005 to that in 2008?
Your response must be concise. 0.79. What is the ratio of the Taxes (in US$) of St. Kitts and Nevis in 2005 to that in 2008?
Your response must be concise. 0.74. What is the ratio of the Taxes (in US$) in Bosnia and Herzegovina in 2005 to that in 2009?
Provide a succinct answer. 0.75. What is the ratio of the Taxes (in US$) of Burkina Faso in 2005 to that in 2009?
Provide a succinct answer. 0.78. What is the ratio of the Taxes (in US$) of Gabon in 2005 to that in 2009?
Your response must be concise. 0.63. What is the ratio of the Taxes (in US$) of St. Kitts and Nevis in 2005 to that in 2009?
Make the answer very short. 0.87. What is the ratio of the Taxes (in US$) in Bosnia and Herzegovina in 2005 to that in 2010?
Provide a short and direct response. 0.7. What is the ratio of the Taxes (in US$) in Burkina Faso in 2005 to that in 2010?
Your answer should be compact. 0.72. What is the ratio of the Taxes (in US$) in Gabon in 2005 to that in 2010?
Ensure brevity in your answer.  0.46. What is the ratio of the Taxes (in US$) of St. Kitts and Nevis in 2005 to that in 2010?
Give a very brief answer. 0.85. What is the ratio of the Taxes (in US$) of Bosnia and Herzegovina in 2006 to that in 2007?
Your answer should be compact. 0.89. What is the ratio of the Taxes (in US$) in Burkina Faso in 2006 to that in 2007?
Your answer should be very brief. 0.9. What is the ratio of the Taxes (in US$) in Gabon in 2006 to that in 2007?
Ensure brevity in your answer.  0.65. What is the ratio of the Taxes (in US$) in St. Kitts and Nevis in 2006 to that in 2007?
Offer a terse response. 1.05. What is the ratio of the Taxes (in US$) in Bosnia and Herzegovina in 2006 to that in 2008?
Offer a very short reply. 0.87. What is the ratio of the Taxes (in US$) of Burkina Faso in 2006 to that in 2008?
Make the answer very short. 0.82. What is the ratio of the Taxes (in US$) of Gabon in 2006 to that in 2008?
Your answer should be very brief. 0.71. What is the ratio of the Taxes (in US$) in St. Kitts and Nevis in 2006 to that in 2008?
Offer a terse response. 0.93. What is the ratio of the Taxes (in US$) of Bosnia and Herzegovina in 2006 to that in 2009?
Offer a very short reply. 0.98. What is the ratio of the Taxes (in US$) in Burkina Faso in 2006 to that in 2009?
Offer a very short reply. 0.69. What is the ratio of the Taxes (in US$) in Gabon in 2006 to that in 2009?
Give a very brief answer. 0.57. What is the ratio of the Taxes (in US$) of St. Kitts and Nevis in 2006 to that in 2009?
Provide a succinct answer. 1.1. What is the ratio of the Taxes (in US$) of Bosnia and Herzegovina in 2006 to that in 2010?
Your answer should be very brief. 0.91. What is the ratio of the Taxes (in US$) of Burkina Faso in 2006 to that in 2010?
Provide a short and direct response. 0.63. What is the ratio of the Taxes (in US$) of Gabon in 2006 to that in 2010?
Your response must be concise. 0.42. What is the ratio of the Taxes (in US$) in St. Kitts and Nevis in 2006 to that in 2010?
Your answer should be very brief. 1.08. What is the ratio of the Taxes (in US$) of Bosnia and Herzegovina in 2007 to that in 2008?
Ensure brevity in your answer.  0.99. What is the ratio of the Taxes (in US$) of Burkina Faso in 2007 to that in 2008?
Your answer should be very brief. 0.91. What is the ratio of the Taxes (in US$) of Gabon in 2007 to that in 2008?
Your response must be concise. 1.1. What is the ratio of the Taxes (in US$) of St. Kitts and Nevis in 2007 to that in 2008?
Keep it short and to the point. 0.89. What is the ratio of the Taxes (in US$) of Bosnia and Herzegovina in 2007 to that in 2009?
Provide a succinct answer. 1.1. What is the ratio of the Taxes (in US$) in Burkina Faso in 2007 to that in 2009?
Provide a succinct answer. 0.77. What is the ratio of the Taxes (in US$) in Gabon in 2007 to that in 2009?
Your answer should be compact. 0.88. What is the ratio of the Taxes (in US$) in St. Kitts and Nevis in 2007 to that in 2009?
Your response must be concise. 1.05. What is the ratio of the Taxes (in US$) in Bosnia and Herzegovina in 2007 to that in 2010?
Your answer should be very brief. 1.03. What is the ratio of the Taxes (in US$) in Burkina Faso in 2007 to that in 2010?
Give a very brief answer. 0.71. What is the ratio of the Taxes (in US$) in Gabon in 2007 to that in 2010?
Your answer should be compact. 0.64. What is the ratio of the Taxes (in US$) in St. Kitts and Nevis in 2007 to that in 2010?
Keep it short and to the point. 1.03. What is the ratio of the Taxes (in US$) in Bosnia and Herzegovina in 2008 to that in 2009?
Give a very brief answer. 1.12. What is the ratio of the Taxes (in US$) in Burkina Faso in 2008 to that in 2009?
Make the answer very short. 0.84. What is the ratio of the Taxes (in US$) in Gabon in 2008 to that in 2009?
Provide a short and direct response. 0.8. What is the ratio of the Taxes (in US$) in St. Kitts and Nevis in 2008 to that in 2009?
Provide a short and direct response. 1.18. What is the ratio of the Taxes (in US$) in Bosnia and Herzegovina in 2008 to that in 2010?
Your answer should be very brief. 1.05. What is the ratio of the Taxes (in US$) of Burkina Faso in 2008 to that in 2010?
Your answer should be very brief. 0.78. What is the ratio of the Taxes (in US$) of Gabon in 2008 to that in 2010?
Your answer should be very brief. 0.58. What is the ratio of the Taxes (in US$) of St. Kitts and Nevis in 2008 to that in 2010?
Offer a very short reply. 1.16. What is the ratio of the Taxes (in US$) of Bosnia and Herzegovina in 2009 to that in 2010?
Your response must be concise. 0.93. What is the ratio of the Taxes (in US$) in Burkina Faso in 2009 to that in 2010?
Your response must be concise. 0.92. What is the ratio of the Taxes (in US$) of Gabon in 2009 to that in 2010?
Keep it short and to the point. 0.73. What is the ratio of the Taxes (in US$) in St. Kitts and Nevis in 2009 to that in 2010?
Ensure brevity in your answer.  0.98. What is the difference between the highest and the second highest Taxes (in US$) in Bosnia and Herzegovina?
Your answer should be compact. 6.51e+07. What is the difference between the highest and the second highest Taxes (in US$) in Burkina Faso?
Provide a succinct answer. 3.09e+1. What is the difference between the highest and the second highest Taxes (in US$) of Gabon?
Your answer should be very brief. 1.63e+11. What is the difference between the highest and the second highest Taxes (in US$) in St. Kitts and Nevis?
Provide a short and direct response. 1.77e+07. What is the difference between the highest and the lowest Taxes (in US$) of Bosnia and Herzegovina?
Your answer should be very brief. 1.98e+09. What is the difference between the highest and the lowest Taxes (in US$) in Burkina Faso?
Keep it short and to the point. 1.69e+11. What is the difference between the highest and the lowest Taxes (in US$) in Gabon?
Make the answer very short. 3.52e+11. What is the difference between the highest and the lowest Taxes (in US$) of St. Kitts and Nevis?
Offer a very short reply. 9.12e+07. 